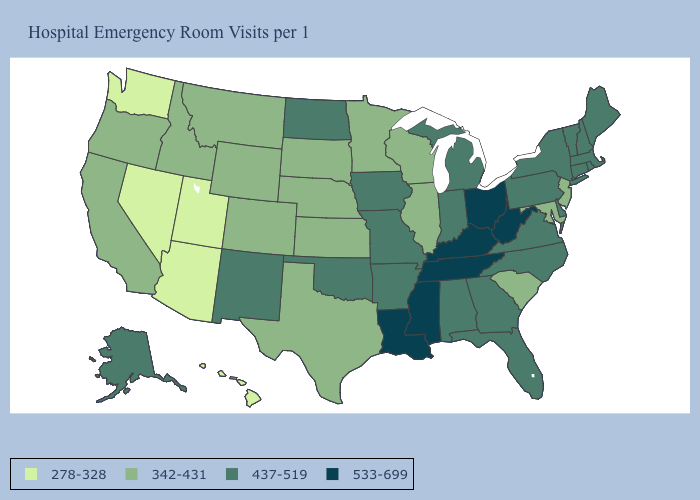Does Minnesota have the same value as Hawaii?
Give a very brief answer. No. What is the value of Missouri?
Be succinct. 437-519. Is the legend a continuous bar?
Answer briefly. No. Name the states that have a value in the range 533-699?
Keep it brief. Kentucky, Louisiana, Mississippi, Ohio, Tennessee, West Virginia. Does Tennessee have a lower value than Nevada?
Quick response, please. No. Does Connecticut have the lowest value in the Northeast?
Short answer required. No. Does Connecticut have the highest value in the USA?
Keep it brief. No. Does Pennsylvania have the same value as South Carolina?
Short answer required. No. What is the value of Washington?
Concise answer only. 278-328. Which states hav the highest value in the Northeast?
Give a very brief answer. Connecticut, Maine, Massachusetts, New Hampshire, New York, Pennsylvania, Rhode Island, Vermont. Does Illinois have the highest value in the MidWest?
Give a very brief answer. No. Among the states that border Oregon , does Idaho have the highest value?
Write a very short answer. Yes. What is the value of Texas?
Answer briefly. 342-431. What is the value of Ohio?
Concise answer only. 533-699. Name the states that have a value in the range 278-328?
Keep it brief. Arizona, Hawaii, Nevada, Utah, Washington. 